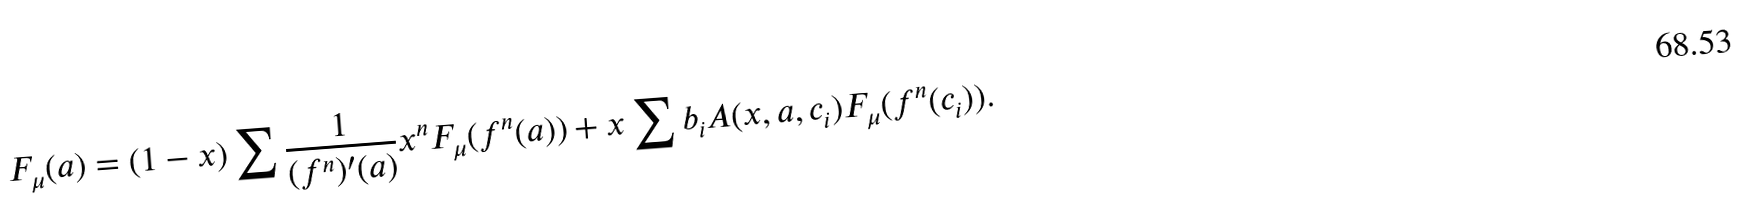Convert formula to latex. <formula><loc_0><loc_0><loc_500><loc_500>F _ { \mu } ( a ) = ( 1 - x ) \sum \frac { 1 } { ( f ^ { n } ) ^ { \prime } ( a ) } x ^ { n } F _ { \mu } ( f ^ { n } ( a ) ) + x \sum b _ { i } A ( x , a , c _ { i } ) F _ { \mu } ( f ^ { n } ( c _ { i } ) ) .</formula> 